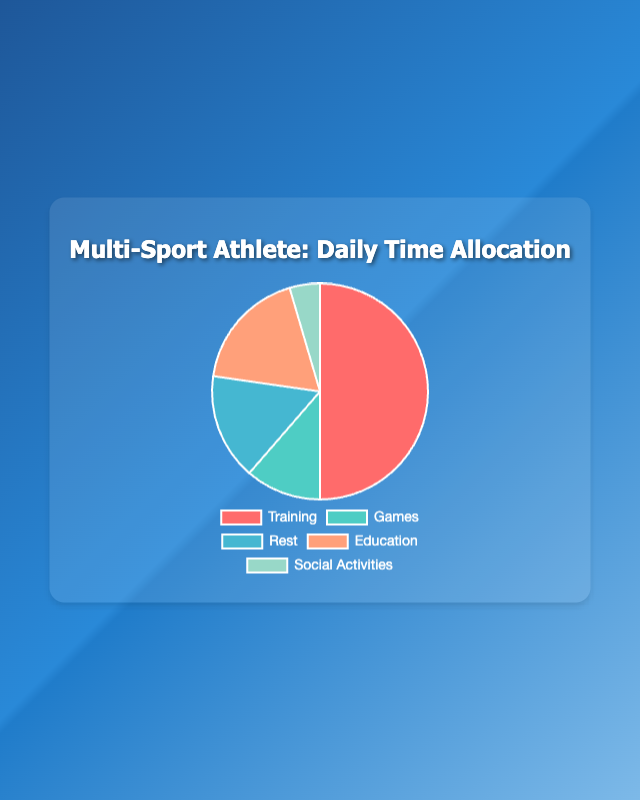What is the category with the highest time allocation? To determine the category with the highest time allocation, look at the section of the pie chart that occupies the largest area. The "Training" section takes up the most space.
Answer: Training Which category has the least time allocation? Look at the section of the pie chart that occupies the smallest area. The "Social Activities" section is the smallest.
Answer: Social Activities Compare the time spent on Training and Games. How much more time is spent on Training compared to Games? Identify the time allocation for both Training (22 hours) and Games (5 hours). Subtract the time allocated to Games from the time allocated to Training: 22 - 5 = 17 hours.
Answer: 17 hours What is the total time spent on Rest and Education combined? Identify the time allocation for Rest (7 hours) and Education (8 hours). Add them together: 7 + 8 = 15 hours.
Answer: 15 hours How much more time is spent on Training than on the combined total of Rest and Social Activities? Identify the time allocation for Rest (7 hours) and Social Activities (2 hours). Add them together: 7 + 2 = 9 hours. Then subtract this total from Training's time allocation: 22 - 9 = 13 hours.
Answer: 13 hours What is the average time allocation across all categories? Sum the time allocated to all categories: 22 (Training) + 5 (Games) + 7 (Rest) + 8 (Education) + 2 (Social Activities) = 44 hours. Then divide by the number of categories (5): 44 / 5 = 8.8 hours.
Answer: 8.8 hours Which category has the second highest time allocation? Identify the category with the highest time allocation, which is Training (22 hours). Then find the next largest, which is Education (8 hours).
Answer: Education What is the combined percentage of time spent on Social Activities and Games relative to the total time? Sum the time allocated to Social Activities (2 hours) and Games (5 hours): 2 + 5 = 7 hours. Then, find the percentage relative to the total time (44 hours): (7 / 44) * 100 ≈ 15.91%.
Answer: 15.91% Is the time spent on Education more than twice the time spent on Social Activities? Identify the time allocated for Education (8 hours) and Social Activities (2 hours). Calculate twice the time spent on Social Activities (2 * 2 = 4 hours). Compare the two values: 8 hours (Education) is indeed more than 4 hours.
Answer: Yes 